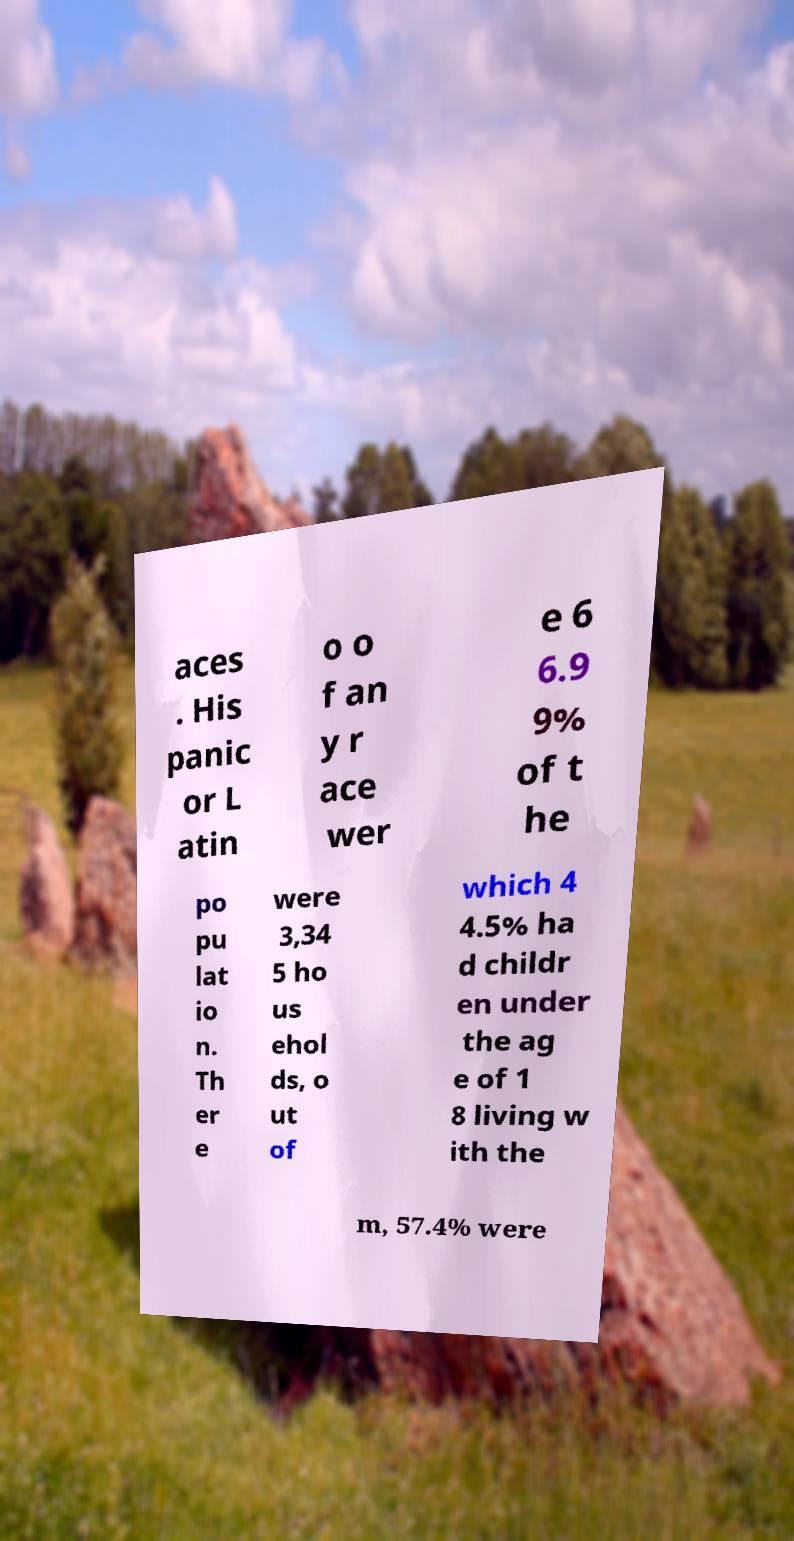There's text embedded in this image that I need extracted. Can you transcribe it verbatim? aces . His panic or L atin o o f an y r ace wer e 6 6.9 9% of t he po pu lat io n. Th er e were 3,34 5 ho us ehol ds, o ut of which 4 4.5% ha d childr en under the ag e of 1 8 living w ith the m, 57.4% were 